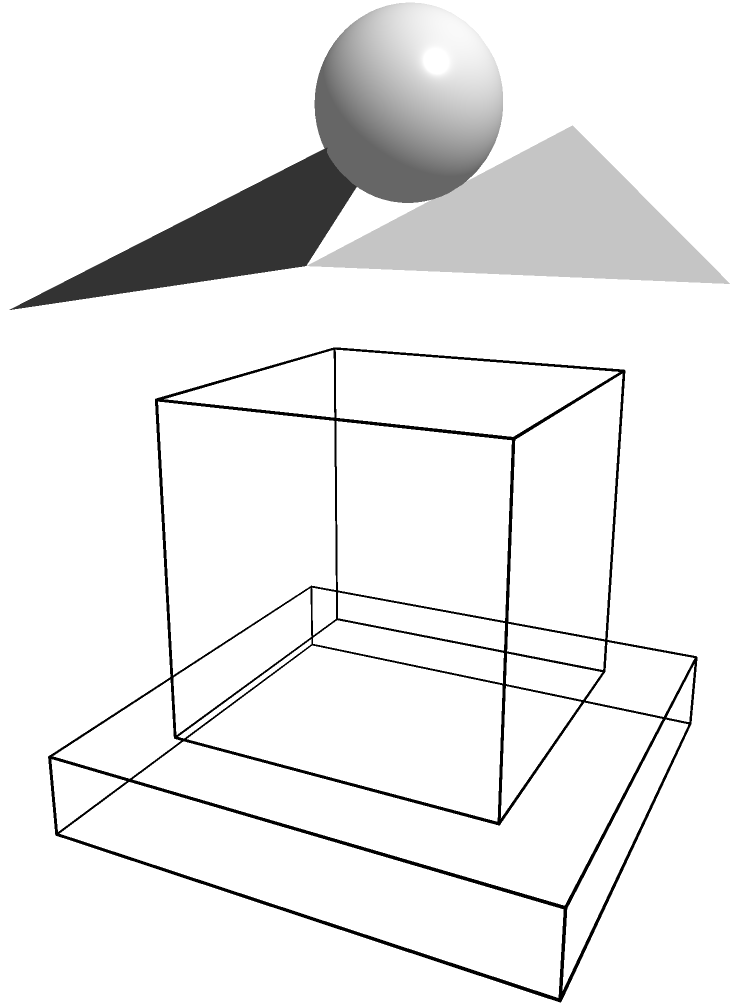In our village's ancient temple, there's a legend about a hidden chamber beneath the main structure. If we were to mentally rotate the temple 90 degrees clockwise around its vertical axis, how many supporting pillars would be visible from the new front view? Let's approach this step-by-step:

1. First, we need to understand the current structure of the temple:
   - The temple has a square base with a main structure on top.
   - There are four pillars, one at each corner of the main structure.

2. Now, let's visualize the rotation:
   - We're rotating the temple 90 degrees clockwise around its vertical axis.
   - This means what was previously the side view will become the front view.

3. In the current front view, we can see:
   - Two pillars at the front corners of the structure.

4. After the 90-degree rotation:
   - The side that was previously hidden will now be in front.
   - This side also has two pillars at its corners.

5. Therefore, after the rotation, we would still see two pillars from the new front view.

It's important to note that while the temple's orientation has changed, the number of visible pillars from the front remains the same due to the symmetrical nature of the structure.
Answer: 2 pillars 